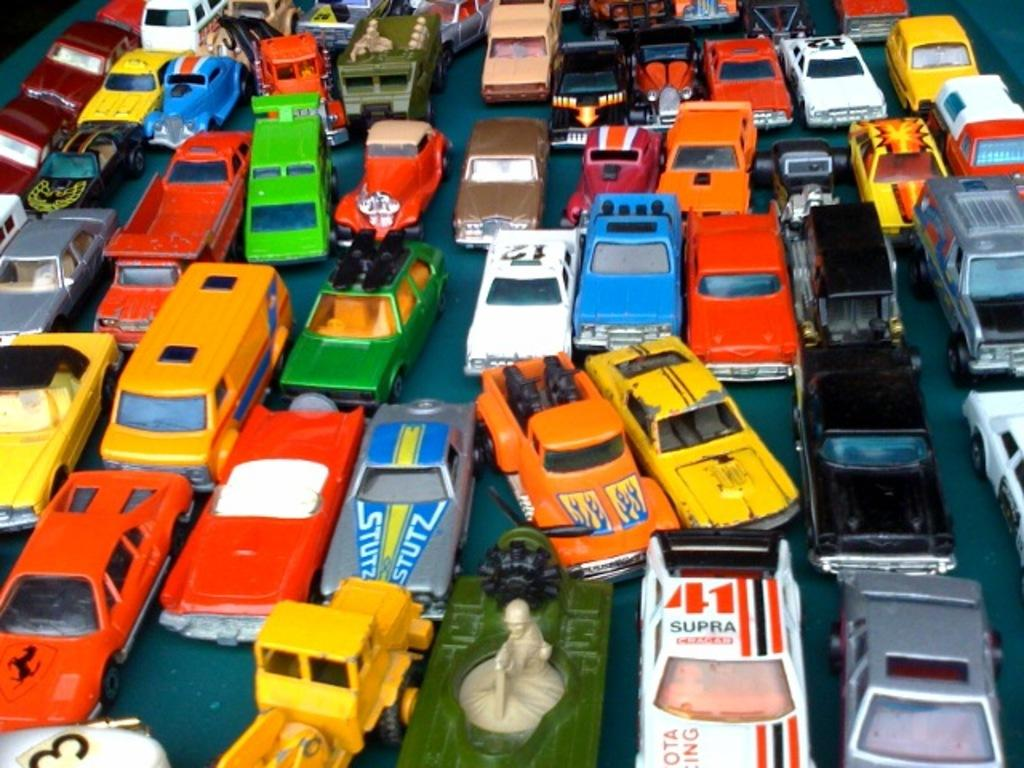<image>
Share a concise interpretation of the image provided. Many toy cars are shown in a group including one that says 41 Supra and another that says Stutz. 